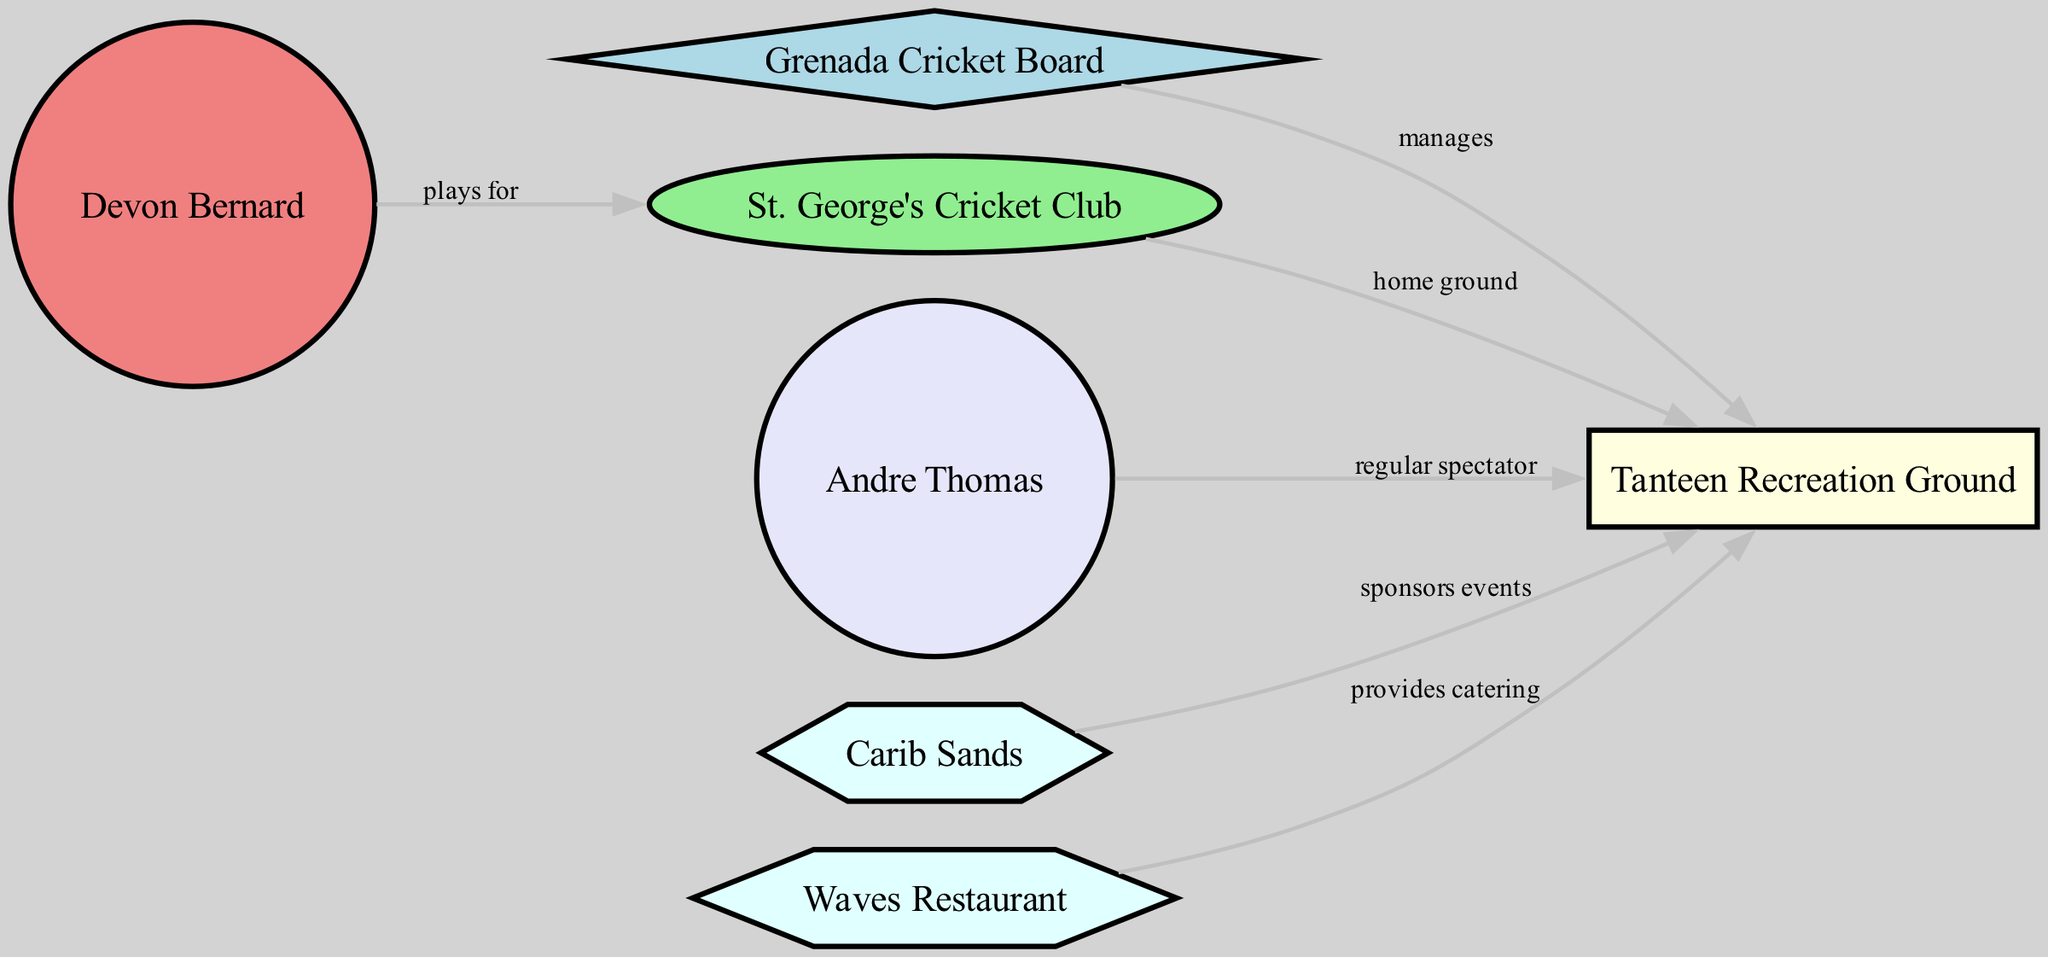What is the home ground of St. George's Cricket Club? The edge from SGCC to TRG is labeled "home ground", indicating that Tanteen Recreation Ground is associated with St. George's Cricket Club.
Answer: Tanteen Recreation Ground How many businesses are associated with Tanteen Recreation Ground? The diagram shows two edges from CS and WV to TRG, indicating that there are two businesses associated with the venue.
Answer: 2 Who manages Tanteen Recreation Ground? The edge from GCB to TRG is labeled "manages", indicating that the Grenada Cricket Board is responsible for managing the ground.
Answer: Grenada Cricket Board Which player plays for St. George's Cricket Club? The edge from DB to SGCC is labeled "plays for", indicating that Devon Bernard is the player representing St. George's Cricket Club.
Answer: Devon Bernard What is the role of Carib Sands in relation to Tanteen Recreation Ground? The edge from CS to TRG is labeled "sponsors events", indicating that Carib Sands is involved in sponsoring events at the ground.
Answer: sponsors events Which type of node represents the fans in the diagram? The node labeled "Andre Thomas" is categorized under the type "fan", which is represented with a circle shape in the diagram.
Answer: fan Who provides catering for Tanteen Recreation Ground? The edge from WV to TRG is labeled "provides catering", indicating that Waves Restaurant is responsible for catering services at the venue.
Answer: Waves Restaurant Which organization is connected to both the ground and the team? GCB is connected to TRG through the "manages" relationship and is implied to be affiliated with SGCC indirectly through cricket governance; thus, GCB connects the venue and team.
Answer: Grenada Cricket Board 